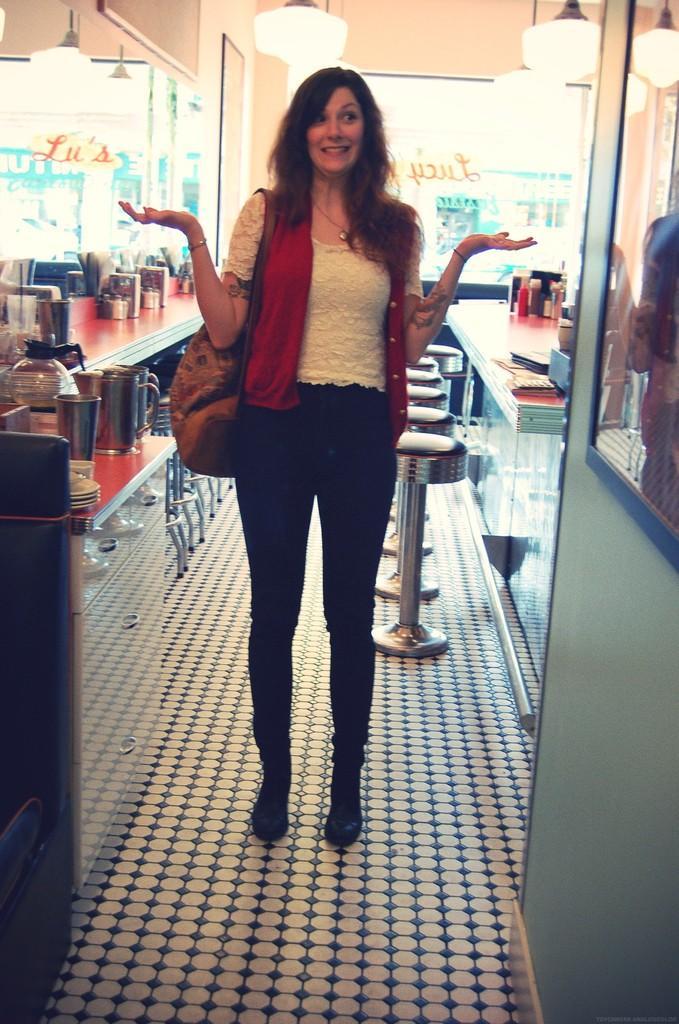How would you summarize this image in a sentence or two? In the picture I can see a woman wearing white color dress, jeans and shoes is standing here and carrying a handbag in her hand. On the either side of the image I can see the glass doors, I can see some objects are placed on the table, I can see chairs and I can see the ceiling lights in the background. 